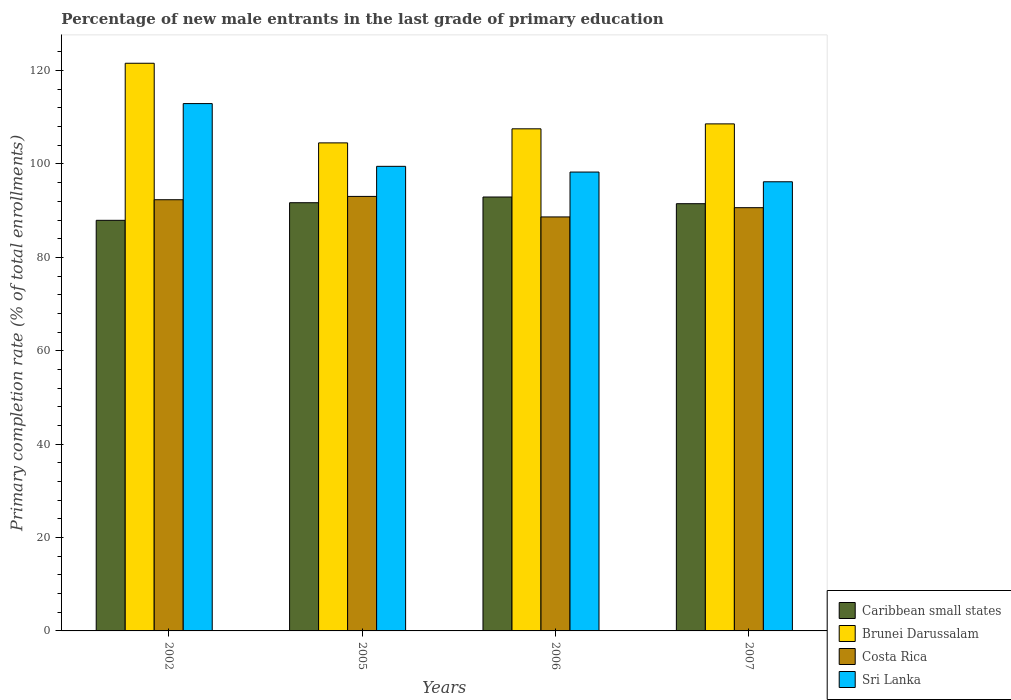How many different coloured bars are there?
Offer a very short reply. 4. Are the number of bars per tick equal to the number of legend labels?
Your response must be concise. Yes. What is the percentage of new male entrants in Brunei Darussalam in 2007?
Your answer should be compact. 108.59. Across all years, what is the maximum percentage of new male entrants in Caribbean small states?
Provide a short and direct response. 92.93. Across all years, what is the minimum percentage of new male entrants in Costa Rica?
Make the answer very short. 88.66. In which year was the percentage of new male entrants in Brunei Darussalam minimum?
Your response must be concise. 2005. What is the total percentage of new male entrants in Caribbean small states in the graph?
Offer a very short reply. 364.07. What is the difference between the percentage of new male entrants in Brunei Darussalam in 2002 and that in 2007?
Your answer should be compact. 12.98. What is the difference between the percentage of new male entrants in Caribbean small states in 2005 and the percentage of new male entrants in Costa Rica in 2006?
Ensure brevity in your answer.  3.04. What is the average percentage of new male entrants in Sri Lanka per year?
Offer a very short reply. 101.72. In the year 2007, what is the difference between the percentage of new male entrants in Costa Rica and percentage of new male entrants in Sri Lanka?
Give a very brief answer. -5.55. What is the ratio of the percentage of new male entrants in Caribbean small states in 2005 to that in 2006?
Provide a succinct answer. 0.99. Is the difference between the percentage of new male entrants in Costa Rica in 2002 and 2006 greater than the difference between the percentage of new male entrants in Sri Lanka in 2002 and 2006?
Offer a very short reply. No. What is the difference between the highest and the second highest percentage of new male entrants in Caribbean small states?
Your answer should be compact. 1.22. What is the difference between the highest and the lowest percentage of new male entrants in Sri Lanka?
Offer a very short reply. 16.74. In how many years, is the percentage of new male entrants in Sri Lanka greater than the average percentage of new male entrants in Sri Lanka taken over all years?
Ensure brevity in your answer.  1. Is the sum of the percentage of new male entrants in Costa Rica in 2005 and 2007 greater than the maximum percentage of new male entrants in Brunei Darussalam across all years?
Ensure brevity in your answer.  Yes. Is it the case that in every year, the sum of the percentage of new male entrants in Sri Lanka and percentage of new male entrants in Brunei Darussalam is greater than the sum of percentage of new male entrants in Costa Rica and percentage of new male entrants in Caribbean small states?
Your response must be concise. No. What does the 1st bar from the left in 2002 represents?
Your response must be concise. Caribbean small states. What does the 3rd bar from the right in 2007 represents?
Your response must be concise. Brunei Darussalam. How many bars are there?
Your answer should be compact. 16. What is the difference between two consecutive major ticks on the Y-axis?
Provide a succinct answer. 20. Are the values on the major ticks of Y-axis written in scientific E-notation?
Provide a short and direct response. No. Does the graph contain any zero values?
Give a very brief answer. No. Does the graph contain grids?
Provide a short and direct response. No. Where does the legend appear in the graph?
Make the answer very short. Bottom right. How many legend labels are there?
Offer a very short reply. 4. What is the title of the graph?
Your answer should be compact. Percentage of new male entrants in the last grade of primary education. Does "Maldives" appear as one of the legend labels in the graph?
Offer a terse response. No. What is the label or title of the X-axis?
Your answer should be compact. Years. What is the label or title of the Y-axis?
Your answer should be compact. Primary completion rate (% of total enrollments). What is the Primary completion rate (% of total enrollments) of Caribbean small states in 2002?
Provide a short and direct response. 87.94. What is the Primary completion rate (% of total enrollments) in Brunei Darussalam in 2002?
Ensure brevity in your answer.  121.57. What is the Primary completion rate (% of total enrollments) of Costa Rica in 2002?
Ensure brevity in your answer.  92.35. What is the Primary completion rate (% of total enrollments) of Sri Lanka in 2002?
Ensure brevity in your answer.  112.94. What is the Primary completion rate (% of total enrollments) of Caribbean small states in 2005?
Keep it short and to the point. 91.71. What is the Primary completion rate (% of total enrollments) of Brunei Darussalam in 2005?
Offer a terse response. 104.52. What is the Primary completion rate (% of total enrollments) in Costa Rica in 2005?
Give a very brief answer. 93.06. What is the Primary completion rate (% of total enrollments) of Sri Lanka in 2005?
Offer a very short reply. 99.5. What is the Primary completion rate (% of total enrollments) in Caribbean small states in 2006?
Give a very brief answer. 92.93. What is the Primary completion rate (% of total enrollments) of Brunei Darussalam in 2006?
Offer a terse response. 107.53. What is the Primary completion rate (% of total enrollments) in Costa Rica in 2006?
Give a very brief answer. 88.66. What is the Primary completion rate (% of total enrollments) of Sri Lanka in 2006?
Your answer should be very brief. 98.27. What is the Primary completion rate (% of total enrollments) in Caribbean small states in 2007?
Provide a succinct answer. 91.5. What is the Primary completion rate (% of total enrollments) in Brunei Darussalam in 2007?
Make the answer very short. 108.59. What is the Primary completion rate (% of total enrollments) in Costa Rica in 2007?
Make the answer very short. 90.64. What is the Primary completion rate (% of total enrollments) of Sri Lanka in 2007?
Your answer should be very brief. 96.19. Across all years, what is the maximum Primary completion rate (% of total enrollments) in Caribbean small states?
Offer a terse response. 92.93. Across all years, what is the maximum Primary completion rate (% of total enrollments) of Brunei Darussalam?
Your answer should be very brief. 121.57. Across all years, what is the maximum Primary completion rate (% of total enrollments) of Costa Rica?
Keep it short and to the point. 93.06. Across all years, what is the maximum Primary completion rate (% of total enrollments) in Sri Lanka?
Offer a terse response. 112.94. Across all years, what is the minimum Primary completion rate (% of total enrollments) of Caribbean small states?
Ensure brevity in your answer.  87.94. Across all years, what is the minimum Primary completion rate (% of total enrollments) in Brunei Darussalam?
Make the answer very short. 104.52. Across all years, what is the minimum Primary completion rate (% of total enrollments) in Costa Rica?
Keep it short and to the point. 88.66. Across all years, what is the minimum Primary completion rate (% of total enrollments) in Sri Lanka?
Keep it short and to the point. 96.19. What is the total Primary completion rate (% of total enrollments) of Caribbean small states in the graph?
Your response must be concise. 364.07. What is the total Primary completion rate (% of total enrollments) in Brunei Darussalam in the graph?
Your answer should be compact. 442.21. What is the total Primary completion rate (% of total enrollments) in Costa Rica in the graph?
Provide a succinct answer. 364.71. What is the total Primary completion rate (% of total enrollments) of Sri Lanka in the graph?
Your response must be concise. 406.9. What is the difference between the Primary completion rate (% of total enrollments) in Caribbean small states in 2002 and that in 2005?
Your response must be concise. -3.77. What is the difference between the Primary completion rate (% of total enrollments) of Brunei Darussalam in 2002 and that in 2005?
Offer a very short reply. 17.05. What is the difference between the Primary completion rate (% of total enrollments) of Costa Rica in 2002 and that in 2005?
Your answer should be very brief. -0.71. What is the difference between the Primary completion rate (% of total enrollments) of Sri Lanka in 2002 and that in 2005?
Your answer should be very brief. 13.44. What is the difference between the Primary completion rate (% of total enrollments) in Caribbean small states in 2002 and that in 2006?
Give a very brief answer. -4.99. What is the difference between the Primary completion rate (% of total enrollments) of Brunei Darussalam in 2002 and that in 2006?
Your answer should be compact. 14.04. What is the difference between the Primary completion rate (% of total enrollments) in Costa Rica in 2002 and that in 2006?
Your response must be concise. 3.69. What is the difference between the Primary completion rate (% of total enrollments) of Sri Lanka in 2002 and that in 2006?
Provide a short and direct response. 14.66. What is the difference between the Primary completion rate (% of total enrollments) of Caribbean small states in 2002 and that in 2007?
Your response must be concise. -3.56. What is the difference between the Primary completion rate (% of total enrollments) in Brunei Darussalam in 2002 and that in 2007?
Make the answer very short. 12.98. What is the difference between the Primary completion rate (% of total enrollments) of Costa Rica in 2002 and that in 2007?
Provide a short and direct response. 1.7. What is the difference between the Primary completion rate (% of total enrollments) of Sri Lanka in 2002 and that in 2007?
Ensure brevity in your answer.  16.74. What is the difference between the Primary completion rate (% of total enrollments) in Caribbean small states in 2005 and that in 2006?
Make the answer very short. -1.22. What is the difference between the Primary completion rate (% of total enrollments) in Brunei Darussalam in 2005 and that in 2006?
Your answer should be very brief. -3.01. What is the difference between the Primary completion rate (% of total enrollments) in Costa Rica in 2005 and that in 2006?
Your response must be concise. 4.39. What is the difference between the Primary completion rate (% of total enrollments) of Sri Lanka in 2005 and that in 2006?
Offer a very short reply. 1.22. What is the difference between the Primary completion rate (% of total enrollments) in Caribbean small states in 2005 and that in 2007?
Offer a very short reply. 0.21. What is the difference between the Primary completion rate (% of total enrollments) of Brunei Darussalam in 2005 and that in 2007?
Offer a very short reply. -4.07. What is the difference between the Primary completion rate (% of total enrollments) in Costa Rica in 2005 and that in 2007?
Offer a very short reply. 2.41. What is the difference between the Primary completion rate (% of total enrollments) in Sri Lanka in 2005 and that in 2007?
Provide a short and direct response. 3.3. What is the difference between the Primary completion rate (% of total enrollments) of Caribbean small states in 2006 and that in 2007?
Your answer should be compact. 1.43. What is the difference between the Primary completion rate (% of total enrollments) in Brunei Darussalam in 2006 and that in 2007?
Your answer should be very brief. -1.06. What is the difference between the Primary completion rate (% of total enrollments) of Costa Rica in 2006 and that in 2007?
Offer a very short reply. -1.98. What is the difference between the Primary completion rate (% of total enrollments) of Sri Lanka in 2006 and that in 2007?
Provide a short and direct response. 2.08. What is the difference between the Primary completion rate (% of total enrollments) of Caribbean small states in 2002 and the Primary completion rate (% of total enrollments) of Brunei Darussalam in 2005?
Ensure brevity in your answer.  -16.58. What is the difference between the Primary completion rate (% of total enrollments) in Caribbean small states in 2002 and the Primary completion rate (% of total enrollments) in Costa Rica in 2005?
Make the answer very short. -5.12. What is the difference between the Primary completion rate (% of total enrollments) of Caribbean small states in 2002 and the Primary completion rate (% of total enrollments) of Sri Lanka in 2005?
Give a very brief answer. -11.56. What is the difference between the Primary completion rate (% of total enrollments) in Brunei Darussalam in 2002 and the Primary completion rate (% of total enrollments) in Costa Rica in 2005?
Give a very brief answer. 28.52. What is the difference between the Primary completion rate (% of total enrollments) in Brunei Darussalam in 2002 and the Primary completion rate (% of total enrollments) in Sri Lanka in 2005?
Provide a succinct answer. 22.08. What is the difference between the Primary completion rate (% of total enrollments) of Costa Rica in 2002 and the Primary completion rate (% of total enrollments) of Sri Lanka in 2005?
Your answer should be very brief. -7.15. What is the difference between the Primary completion rate (% of total enrollments) in Caribbean small states in 2002 and the Primary completion rate (% of total enrollments) in Brunei Darussalam in 2006?
Your response must be concise. -19.59. What is the difference between the Primary completion rate (% of total enrollments) of Caribbean small states in 2002 and the Primary completion rate (% of total enrollments) of Costa Rica in 2006?
Your response must be concise. -0.73. What is the difference between the Primary completion rate (% of total enrollments) in Caribbean small states in 2002 and the Primary completion rate (% of total enrollments) in Sri Lanka in 2006?
Your answer should be compact. -10.34. What is the difference between the Primary completion rate (% of total enrollments) in Brunei Darussalam in 2002 and the Primary completion rate (% of total enrollments) in Costa Rica in 2006?
Your response must be concise. 32.91. What is the difference between the Primary completion rate (% of total enrollments) of Brunei Darussalam in 2002 and the Primary completion rate (% of total enrollments) of Sri Lanka in 2006?
Your answer should be compact. 23.3. What is the difference between the Primary completion rate (% of total enrollments) in Costa Rica in 2002 and the Primary completion rate (% of total enrollments) in Sri Lanka in 2006?
Ensure brevity in your answer.  -5.93. What is the difference between the Primary completion rate (% of total enrollments) of Caribbean small states in 2002 and the Primary completion rate (% of total enrollments) of Brunei Darussalam in 2007?
Offer a very short reply. -20.65. What is the difference between the Primary completion rate (% of total enrollments) in Caribbean small states in 2002 and the Primary completion rate (% of total enrollments) in Costa Rica in 2007?
Give a very brief answer. -2.71. What is the difference between the Primary completion rate (% of total enrollments) in Caribbean small states in 2002 and the Primary completion rate (% of total enrollments) in Sri Lanka in 2007?
Offer a very short reply. -8.26. What is the difference between the Primary completion rate (% of total enrollments) of Brunei Darussalam in 2002 and the Primary completion rate (% of total enrollments) of Costa Rica in 2007?
Your answer should be very brief. 30.93. What is the difference between the Primary completion rate (% of total enrollments) in Brunei Darussalam in 2002 and the Primary completion rate (% of total enrollments) in Sri Lanka in 2007?
Your answer should be very brief. 25.38. What is the difference between the Primary completion rate (% of total enrollments) of Costa Rica in 2002 and the Primary completion rate (% of total enrollments) of Sri Lanka in 2007?
Make the answer very short. -3.85. What is the difference between the Primary completion rate (% of total enrollments) in Caribbean small states in 2005 and the Primary completion rate (% of total enrollments) in Brunei Darussalam in 2006?
Your response must be concise. -15.82. What is the difference between the Primary completion rate (% of total enrollments) of Caribbean small states in 2005 and the Primary completion rate (% of total enrollments) of Costa Rica in 2006?
Ensure brevity in your answer.  3.04. What is the difference between the Primary completion rate (% of total enrollments) in Caribbean small states in 2005 and the Primary completion rate (% of total enrollments) in Sri Lanka in 2006?
Your answer should be compact. -6.57. What is the difference between the Primary completion rate (% of total enrollments) in Brunei Darussalam in 2005 and the Primary completion rate (% of total enrollments) in Costa Rica in 2006?
Your response must be concise. 15.86. What is the difference between the Primary completion rate (% of total enrollments) of Brunei Darussalam in 2005 and the Primary completion rate (% of total enrollments) of Sri Lanka in 2006?
Your answer should be very brief. 6.24. What is the difference between the Primary completion rate (% of total enrollments) in Costa Rica in 2005 and the Primary completion rate (% of total enrollments) in Sri Lanka in 2006?
Your answer should be very brief. -5.22. What is the difference between the Primary completion rate (% of total enrollments) of Caribbean small states in 2005 and the Primary completion rate (% of total enrollments) of Brunei Darussalam in 2007?
Offer a terse response. -16.88. What is the difference between the Primary completion rate (% of total enrollments) of Caribbean small states in 2005 and the Primary completion rate (% of total enrollments) of Costa Rica in 2007?
Offer a very short reply. 1.06. What is the difference between the Primary completion rate (% of total enrollments) of Caribbean small states in 2005 and the Primary completion rate (% of total enrollments) of Sri Lanka in 2007?
Provide a short and direct response. -4.49. What is the difference between the Primary completion rate (% of total enrollments) in Brunei Darussalam in 2005 and the Primary completion rate (% of total enrollments) in Costa Rica in 2007?
Offer a very short reply. 13.88. What is the difference between the Primary completion rate (% of total enrollments) of Brunei Darussalam in 2005 and the Primary completion rate (% of total enrollments) of Sri Lanka in 2007?
Your answer should be very brief. 8.33. What is the difference between the Primary completion rate (% of total enrollments) of Costa Rica in 2005 and the Primary completion rate (% of total enrollments) of Sri Lanka in 2007?
Give a very brief answer. -3.14. What is the difference between the Primary completion rate (% of total enrollments) of Caribbean small states in 2006 and the Primary completion rate (% of total enrollments) of Brunei Darussalam in 2007?
Your answer should be very brief. -15.66. What is the difference between the Primary completion rate (% of total enrollments) in Caribbean small states in 2006 and the Primary completion rate (% of total enrollments) in Costa Rica in 2007?
Keep it short and to the point. 2.28. What is the difference between the Primary completion rate (% of total enrollments) in Caribbean small states in 2006 and the Primary completion rate (% of total enrollments) in Sri Lanka in 2007?
Make the answer very short. -3.27. What is the difference between the Primary completion rate (% of total enrollments) of Brunei Darussalam in 2006 and the Primary completion rate (% of total enrollments) of Costa Rica in 2007?
Your answer should be compact. 16.89. What is the difference between the Primary completion rate (% of total enrollments) of Brunei Darussalam in 2006 and the Primary completion rate (% of total enrollments) of Sri Lanka in 2007?
Provide a succinct answer. 11.34. What is the difference between the Primary completion rate (% of total enrollments) in Costa Rica in 2006 and the Primary completion rate (% of total enrollments) in Sri Lanka in 2007?
Offer a terse response. -7.53. What is the average Primary completion rate (% of total enrollments) in Caribbean small states per year?
Make the answer very short. 91.02. What is the average Primary completion rate (% of total enrollments) of Brunei Darussalam per year?
Offer a very short reply. 110.55. What is the average Primary completion rate (% of total enrollments) in Costa Rica per year?
Your answer should be compact. 91.18. What is the average Primary completion rate (% of total enrollments) in Sri Lanka per year?
Make the answer very short. 101.72. In the year 2002, what is the difference between the Primary completion rate (% of total enrollments) in Caribbean small states and Primary completion rate (% of total enrollments) in Brunei Darussalam?
Make the answer very short. -33.64. In the year 2002, what is the difference between the Primary completion rate (% of total enrollments) of Caribbean small states and Primary completion rate (% of total enrollments) of Costa Rica?
Your answer should be very brief. -4.41. In the year 2002, what is the difference between the Primary completion rate (% of total enrollments) of Caribbean small states and Primary completion rate (% of total enrollments) of Sri Lanka?
Your answer should be very brief. -25. In the year 2002, what is the difference between the Primary completion rate (% of total enrollments) of Brunei Darussalam and Primary completion rate (% of total enrollments) of Costa Rica?
Offer a very short reply. 29.23. In the year 2002, what is the difference between the Primary completion rate (% of total enrollments) of Brunei Darussalam and Primary completion rate (% of total enrollments) of Sri Lanka?
Give a very brief answer. 8.64. In the year 2002, what is the difference between the Primary completion rate (% of total enrollments) of Costa Rica and Primary completion rate (% of total enrollments) of Sri Lanka?
Offer a very short reply. -20.59. In the year 2005, what is the difference between the Primary completion rate (% of total enrollments) in Caribbean small states and Primary completion rate (% of total enrollments) in Brunei Darussalam?
Provide a short and direct response. -12.81. In the year 2005, what is the difference between the Primary completion rate (% of total enrollments) of Caribbean small states and Primary completion rate (% of total enrollments) of Costa Rica?
Offer a terse response. -1.35. In the year 2005, what is the difference between the Primary completion rate (% of total enrollments) in Caribbean small states and Primary completion rate (% of total enrollments) in Sri Lanka?
Offer a very short reply. -7.79. In the year 2005, what is the difference between the Primary completion rate (% of total enrollments) of Brunei Darussalam and Primary completion rate (% of total enrollments) of Costa Rica?
Make the answer very short. 11.46. In the year 2005, what is the difference between the Primary completion rate (% of total enrollments) of Brunei Darussalam and Primary completion rate (% of total enrollments) of Sri Lanka?
Give a very brief answer. 5.02. In the year 2005, what is the difference between the Primary completion rate (% of total enrollments) of Costa Rica and Primary completion rate (% of total enrollments) of Sri Lanka?
Offer a terse response. -6.44. In the year 2006, what is the difference between the Primary completion rate (% of total enrollments) in Caribbean small states and Primary completion rate (% of total enrollments) in Brunei Darussalam?
Offer a very short reply. -14.6. In the year 2006, what is the difference between the Primary completion rate (% of total enrollments) in Caribbean small states and Primary completion rate (% of total enrollments) in Costa Rica?
Provide a short and direct response. 4.26. In the year 2006, what is the difference between the Primary completion rate (% of total enrollments) in Caribbean small states and Primary completion rate (% of total enrollments) in Sri Lanka?
Your answer should be very brief. -5.35. In the year 2006, what is the difference between the Primary completion rate (% of total enrollments) of Brunei Darussalam and Primary completion rate (% of total enrollments) of Costa Rica?
Give a very brief answer. 18.87. In the year 2006, what is the difference between the Primary completion rate (% of total enrollments) of Brunei Darussalam and Primary completion rate (% of total enrollments) of Sri Lanka?
Your answer should be very brief. 9.26. In the year 2006, what is the difference between the Primary completion rate (% of total enrollments) of Costa Rica and Primary completion rate (% of total enrollments) of Sri Lanka?
Offer a terse response. -9.61. In the year 2007, what is the difference between the Primary completion rate (% of total enrollments) in Caribbean small states and Primary completion rate (% of total enrollments) in Brunei Darussalam?
Your response must be concise. -17.09. In the year 2007, what is the difference between the Primary completion rate (% of total enrollments) of Caribbean small states and Primary completion rate (% of total enrollments) of Costa Rica?
Your answer should be compact. 0.85. In the year 2007, what is the difference between the Primary completion rate (% of total enrollments) of Caribbean small states and Primary completion rate (% of total enrollments) of Sri Lanka?
Offer a terse response. -4.7. In the year 2007, what is the difference between the Primary completion rate (% of total enrollments) in Brunei Darussalam and Primary completion rate (% of total enrollments) in Costa Rica?
Keep it short and to the point. 17.94. In the year 2007, what is the difference between the Primary completion rate (% of total enrollments) in Brunei Darussalam and Primary completion rate (% of total enrollments) in Sri Lanka?
Make the answer very short. 12.4. In the year 2007, what is the difference between the Primary completion rate (% of total enrollments) of Costa Rica and Primary completion rate (% of total enrollments) of Sri Lanka?
Keep it short and to the point. -5.55. What is the ratio of the Primary completion rate (% of total enrollments) of Caribbean small states in 2002 to that in 2005?
Your response must be concise. 0.96. What is the ratio of the Primary completion rate (% of total enrollments) of Brunei Darussalam in 2002 to that in 2005?
Offer a terse response. 1.16. What is the ratio of the Primary completion rate (% of total enrollments) in Sri Lanka in 2002 to that in 2005?
Offer a terse response. 1.14. What is the ratio of the Primary completion rate (% of total enrollments) of Caribbean small states in 2002 to that in 2006?
Your response must be concise. 0.95. What is the ratio of the Primary completion rate (% of total enrollments) in Brunei Darussalam in 2002 to that in 2006?
Offer a very short reply. 1.13. What is the ratio of the Primary completion rate (% of total enrollments) in Costa Rica in 2002 to that in 2006?
Offer a very short reply. 1.04. What is the ratio of the Primary completion rate (% of total enrollments) in Sri Lanka in 2002 to that in 2006?
Provide a succinct answer. 1.15. What is the ratio of the Primary completion rate (% of total enrollments) in Caribbean small states in 2002 to that in 2007?
Ensure brevity in your answer.  0.96. What is the ratio of the Primary completion rate (% of total enrollments) in Brunei Darussalam in 2002 to that in 2007?
Your answer should be very brief. 1.12. What is the ratio of the Primary completion rate (% of total enrollments) of Costa Rica in 2002 to that in 2007?
Make the answer very short. 1.02. What is the ratio of the Primary completion rate (% of total enrollments) of Sri Lanka in 2002 to that in 2007?
Keep it short and to the point. 1.17. What is the ratio of the Primary completion rate (% of total enrollments) of Caribbean small states in 2005 to that in 2006?
Your answer should be very brief. 0.99. What is the ratio of the Primary completion rate (% of total enrollments) in Costa Rica in 2005 to that in 2006?
Ensure brevity in your answer.  1.05. What is the ratio of the Primary completion rate (% of total enrollments) in Sri Lanka in 2005 to that in 2006?
Keep it short and to the point. 1.01. What is the ratio of the Primary completion rate (% of total enrollments) in Brunei Darussalam in 2005 to that in 2007?
Your answer should be compact. 0.96. What is the ratio of the Primary completion rate (% of total enrollments) of Costa Rica in 2005 to that in 2007?
Provide a short and direct response. 1.03. What is the ratio of the Primary completion rate (% of total enrollments) in Sri Lanka in 2005 to that in 2007?
Your answer should be compact. 1.03. What is the ratio of the Primary completion rate (% of total enrollments) in Caribbean small states in 2006 to that in 2007?
Keep it short and to the point. 1.02. What is the ratio of the Primary completion rate (% of total enrollments) in Brunei Darussalam in 2006 to that in 2007?
Make the answer very short. 0.99. What is the ratio of the Primary completion rate (% of total enrollments) of Costa Rica in 2006 to that in 2007?
Offer a very short reply. 0.98. What is the ratio of the Primary completion rate (% of total enrollments) of Sri Lanka in 2006 to that in 2007?
Your answer should be very brief. 1.02. What is the difference between the highest and the second highest Primary completion rate (% of total enrollments) in Caribbean small states?
Offer a terse response. 1.22. What is the difference between the highest and the second highest Primary completion rate (% of total enrollments) in Brunei Darussalam?
Keep it short and to the point. 12.98. What is the difference between the highest and the second highest Primary completion rate (% of total enrollments) of Costa Rica?
Your answer should be very brief. 0.71. What is the difference between the highest and the second highest Primary completion rate (% of total enrollments) of Sri Lanka?
Your answer should be very brief. 13.44. What is the difference between the highest and the lowest Primary completion rate (% of total enrollments) in Caribbean small states?
Make the answer very short. 4.99. What is the difference between the highest and the lowest Primary completion rate (% of total enrollments) in Brunei Darussalam?
Provide a short and direct response. 17.05. What is the difference between the highest and the lowest Primary completion rate (% of total enrollments) of Costa Rica?
Ensure brevity in your answer.  4.39. What is the difference between the highest and the lowest Primary completion rate (% of total enrollments) of Sri Lanka?
Your response must be concise. 16.74. 